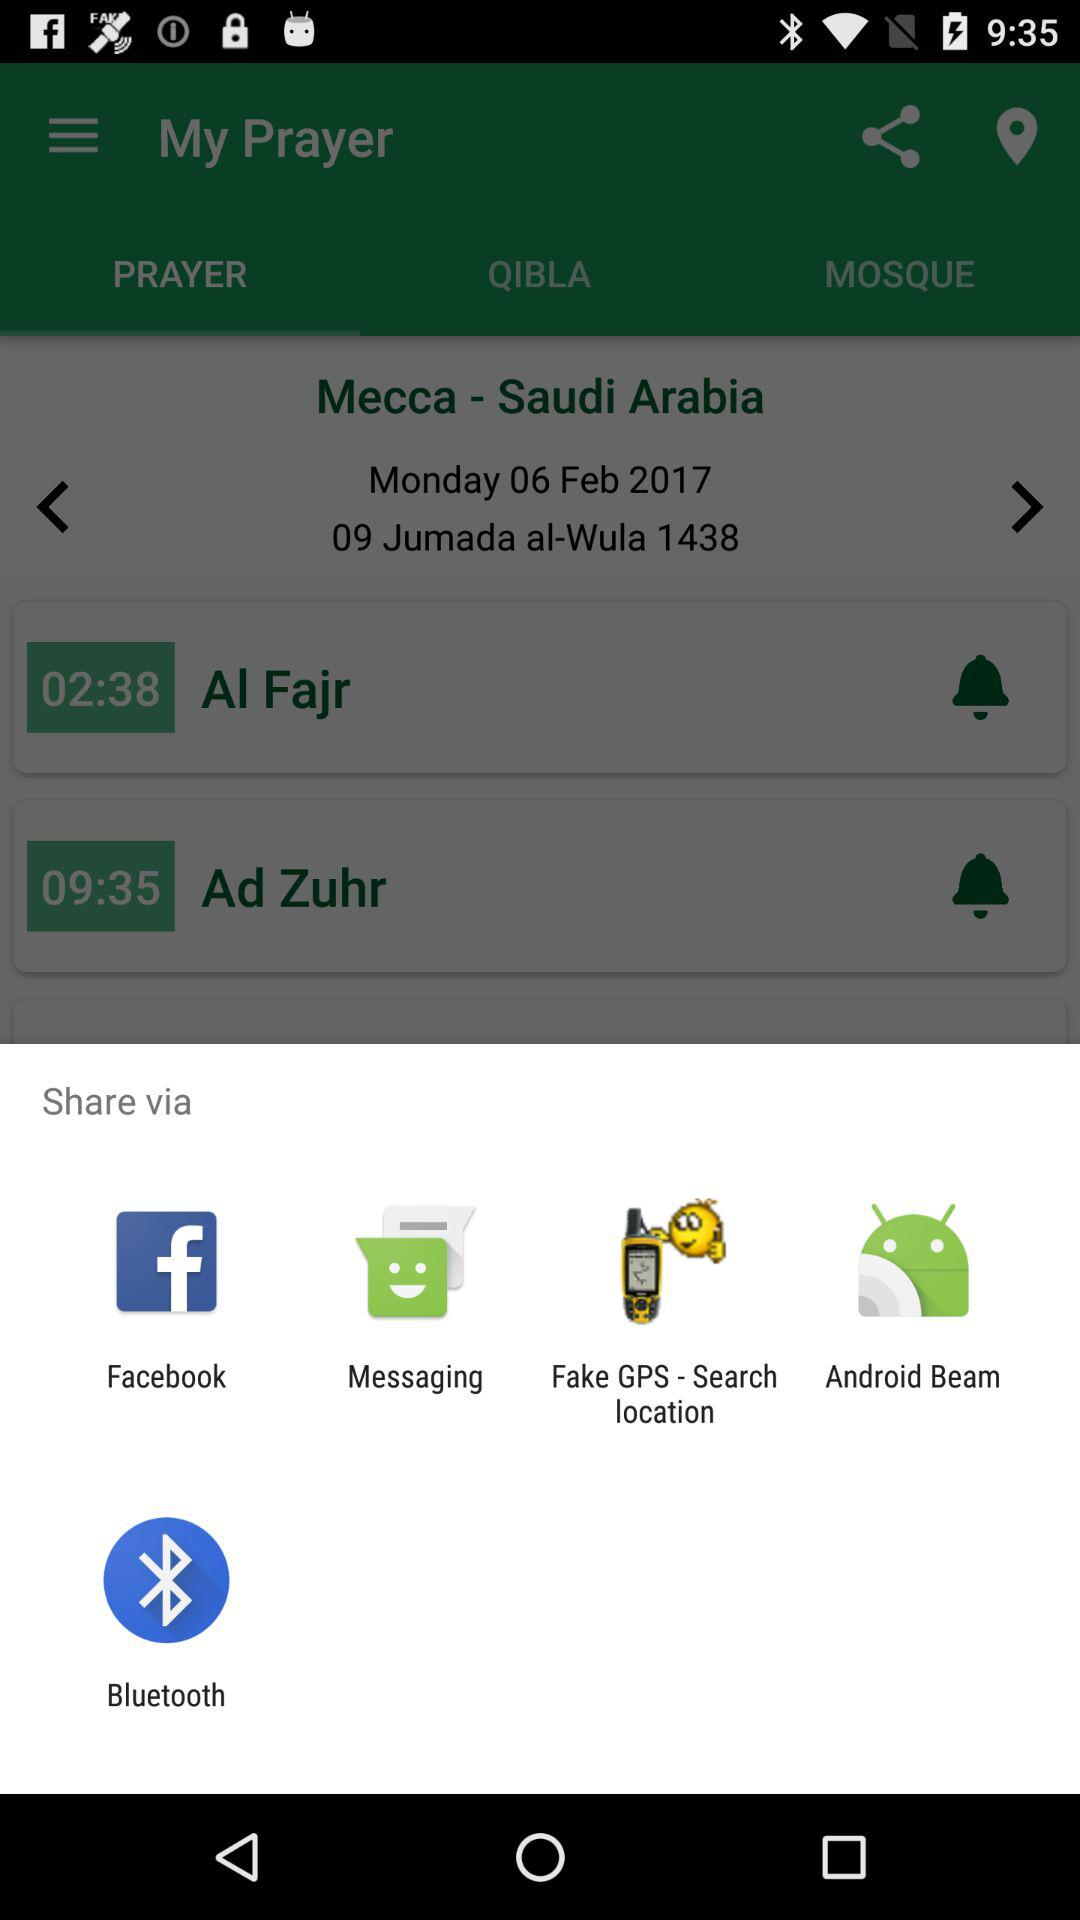Which applications are available for sharing?
When the provided information is insufficient, respond with <no answer>. <no answer> 